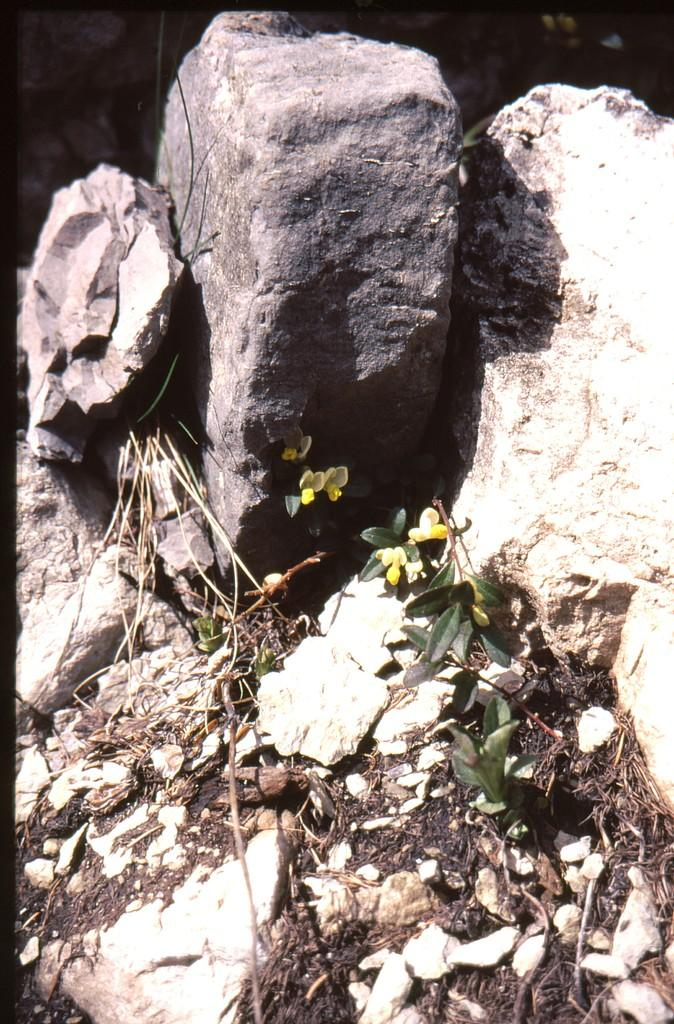What type of natural elements can be seen in the image? There are rocks in the image. What is growing on the rocks? There are plants on the rocks. What other items can be seen on the rocks? Dried stems and dried leaves are present on the rocks. What is the lighting condition at the top of the image? The top of the image appears to be dark. What type of beam is being used to support the rocks in the image? There is no beam present in the image; the rocks are not being supported by any artificial structure. 